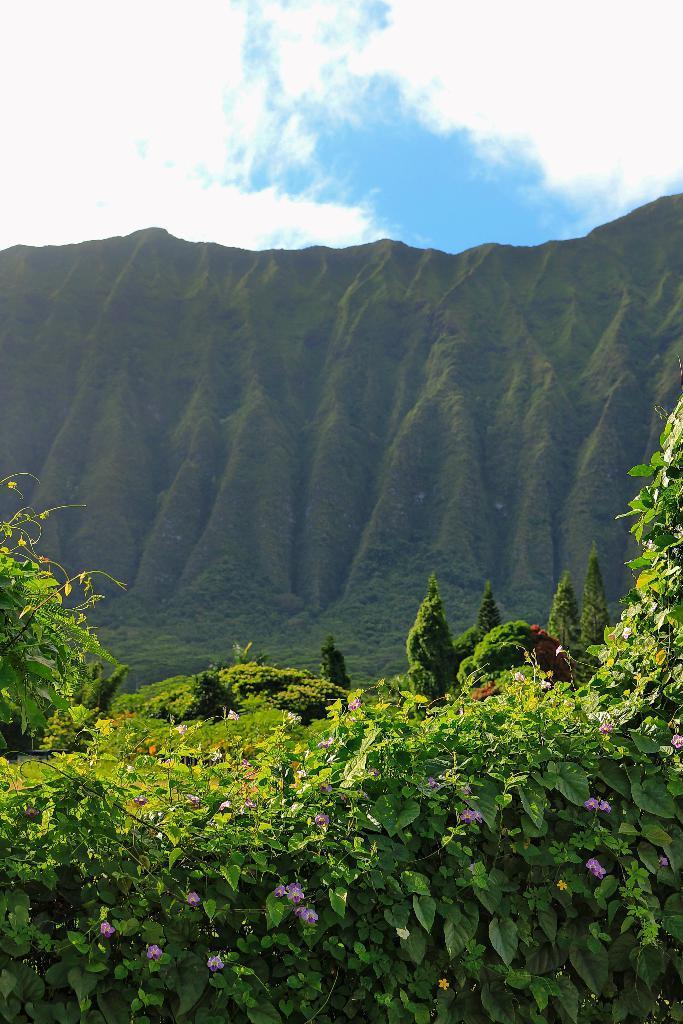Describe this image in one or two sentences. In this image I can see the purple colorful to the plants. In the background I can see the trees, mountains, clouds and the sky. 